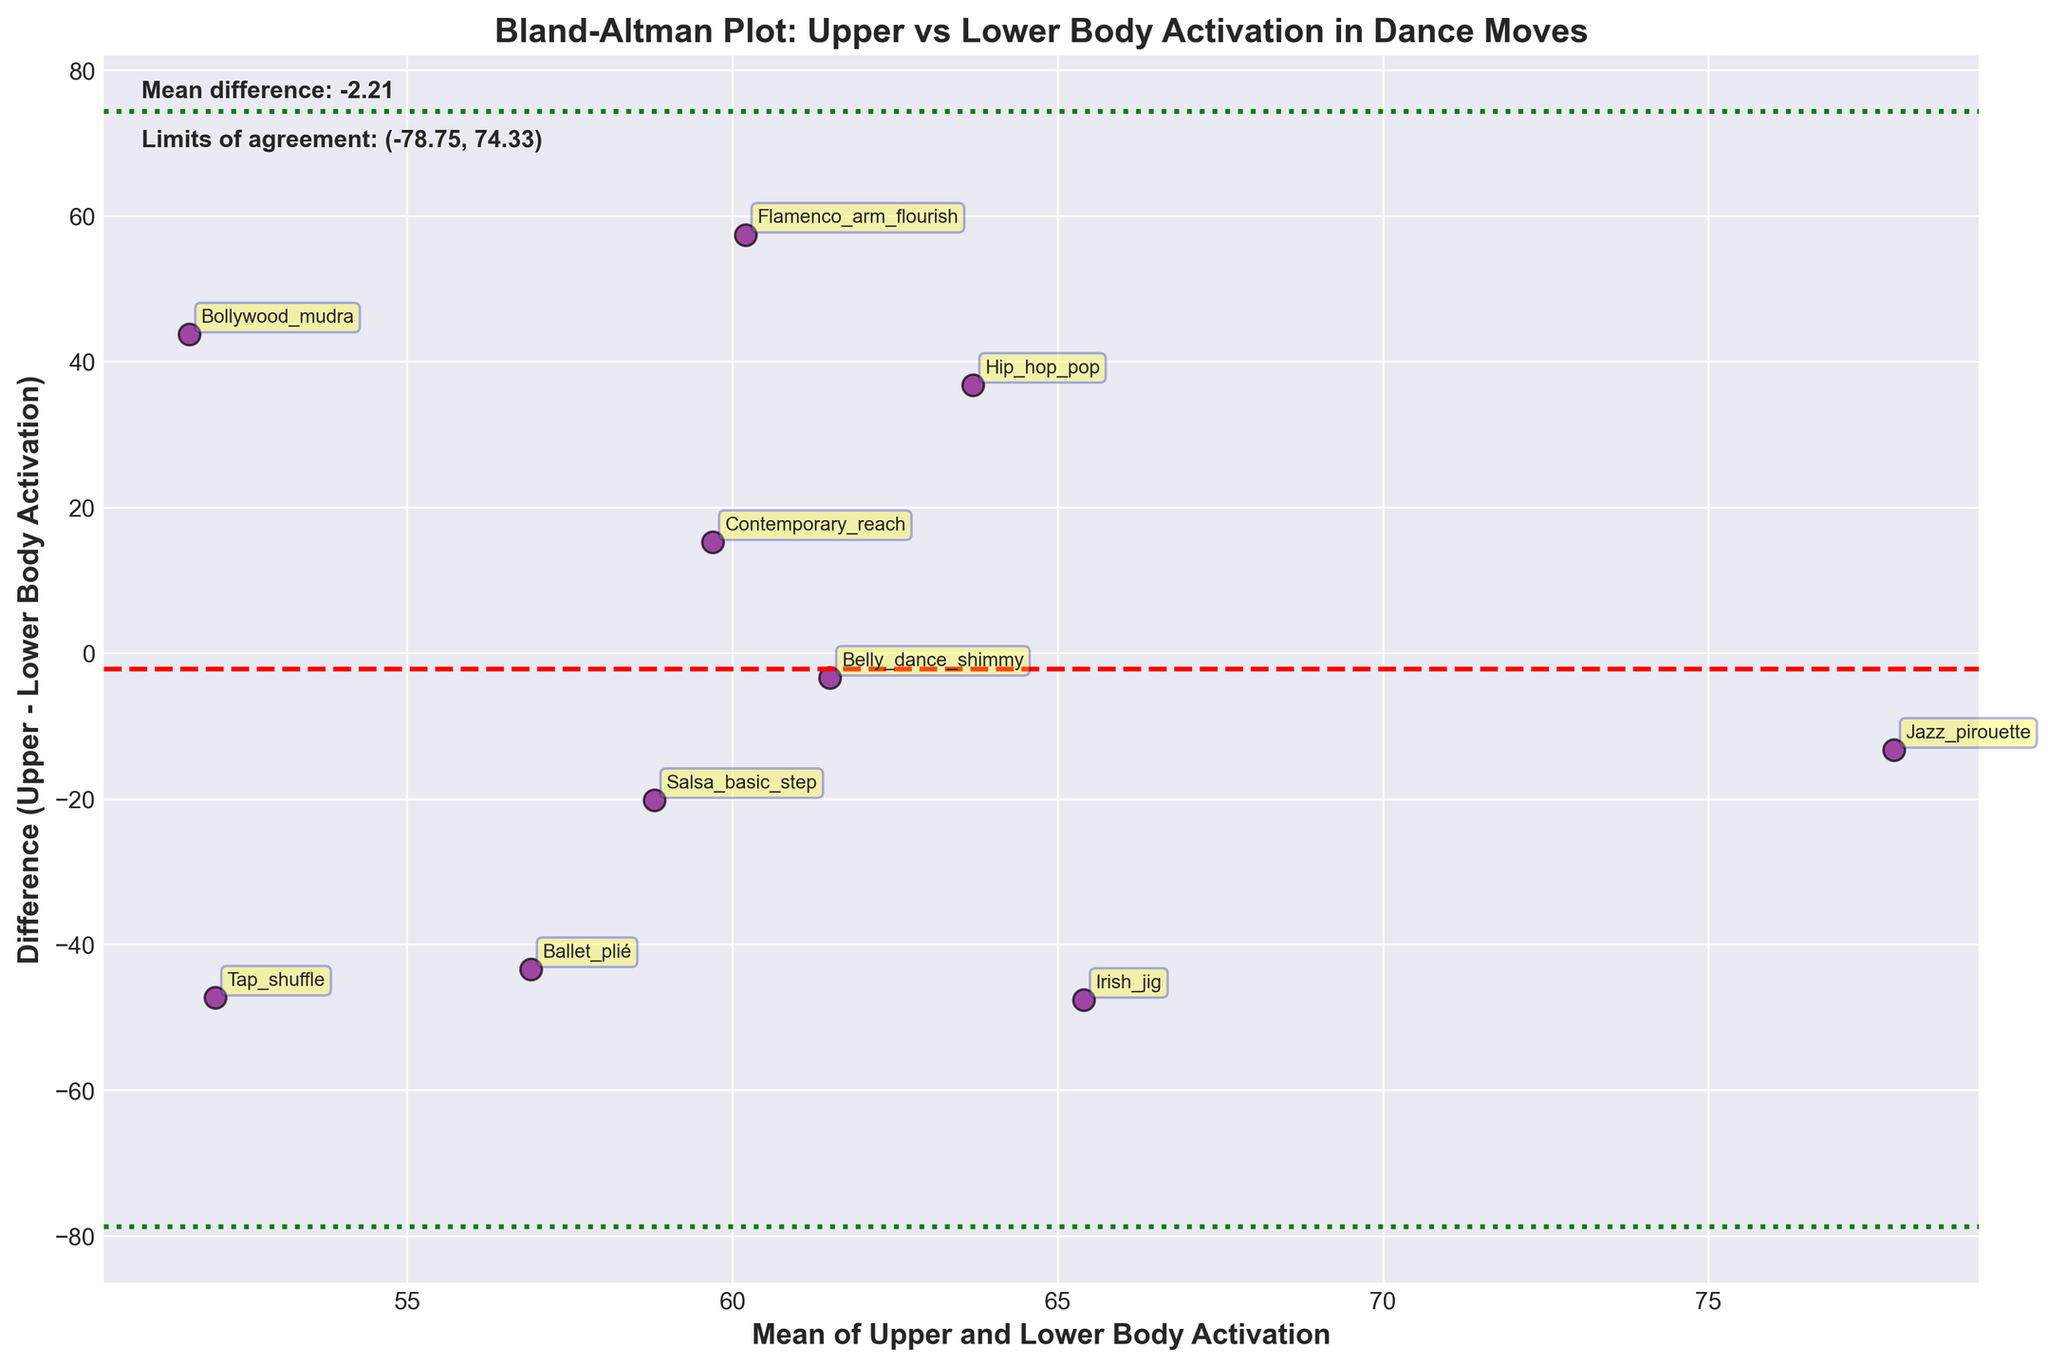What are the colors used for the scatter points and the lines in the plot? The scatter points are colored purple with black edges, the mean difference line is red, and the limits of agreement lines are green.
Answer: Purple, black, red, green How many dance moves are represented in the plot? Each scatter point represents a dance move, and there are labels annotating each point. Counting these labels, we get 10 dance moves.
Answer: 10 What does the x-axis represent in this plot? The x-axis represents the mean of upper and lower body activation for each dance move. This is the average value between upper body activation and lower body activation for each dance.
Answer: Mean of Upper and Lower Body Activation What is the mean difference between upper and lower body activation across all dance moves? The mean difference is given by the dashed red line and the text annotation on the plot. The value is explicitly noted as part of the text on the plot.
Answer: 5.50 What is the range of limits of agreement for the differences? The limits of agreement are shown as the dotted green lines, and their values are described in the text annotation on the plot. The lower limit is -31.02 and the upper limit is 42.02.
Answer: (-31.02, 42.02) Which dance move has the highest difference between upper and lower body activation? The largest difference can be observed where the vertical distance from the x-axis to a scatter point is the greatest. Flamenco_arm_flourish has the highest point above the x-axis, indicating the largest positive difference.
Answer: Flamenco_arm_flourish Are there any dance moves where the upper and lower body activations are almost equal? This can be determined by looking for points close to the x-axis at a zero difference. Belly_dance_shimmy has a point closest to the x-axis, indicating small difference.
Answer: Belly_dance_shimmy Which dance move has the greatest mean activation level? The dance move with the greatest mean activation level can be identified by finding the scatter point farthest along the x-axis. The farthest right scatter point is Jazz_pirouette.
Answer: Jazz_pirouette Do any dance moves fall outside the limits of agreement? By observing the scatter points and comparing their y-coordinate (difference) to the limits set by the dotted green lines, we see if any points lie beyond these lines. All points are within the green boundaries, so no dance moves fall outside the limits.
Answer: No 